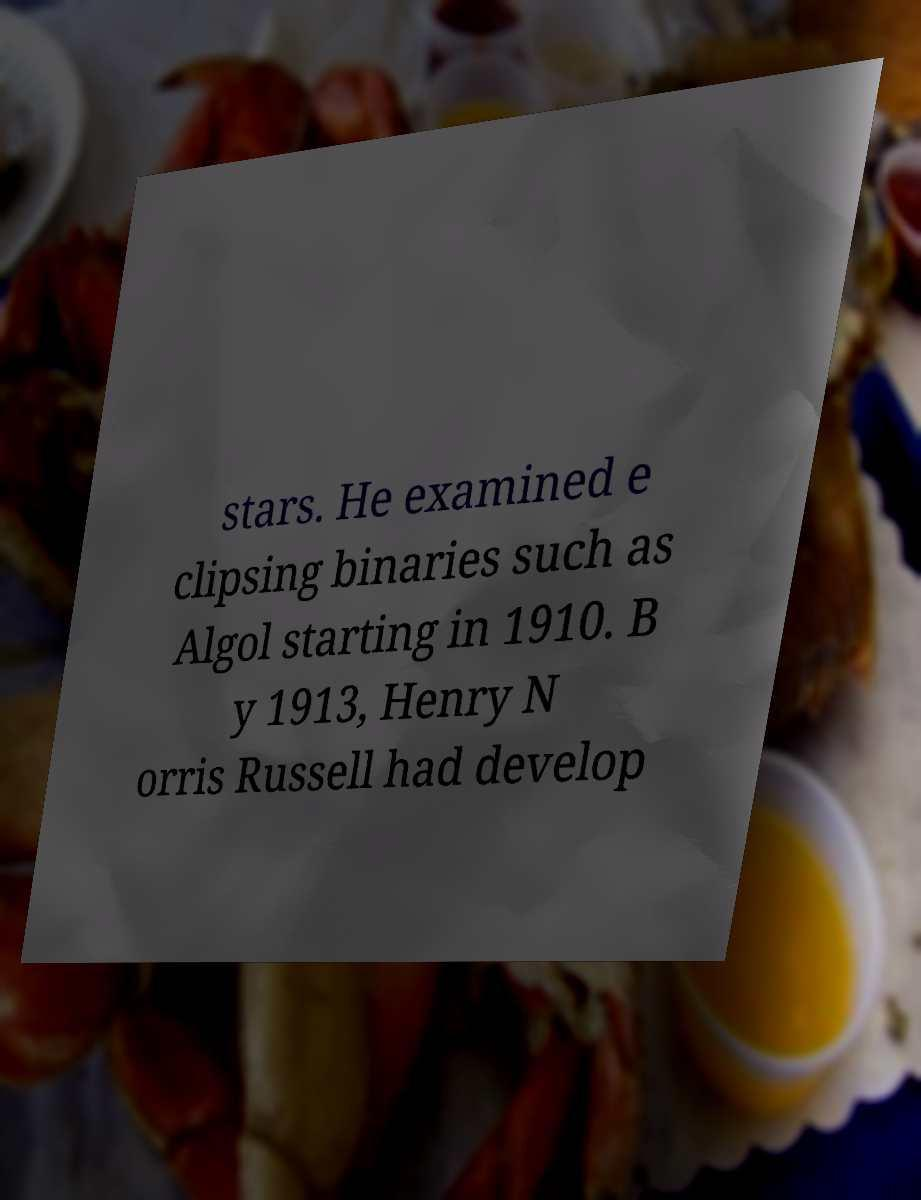There's text embedded in this image that I need extracted. Can you transcribe it verbatim? stars. He examined e clipsing binaries such as Algol starting in 1910. B y 1913, Henry N orris Russell had develop 